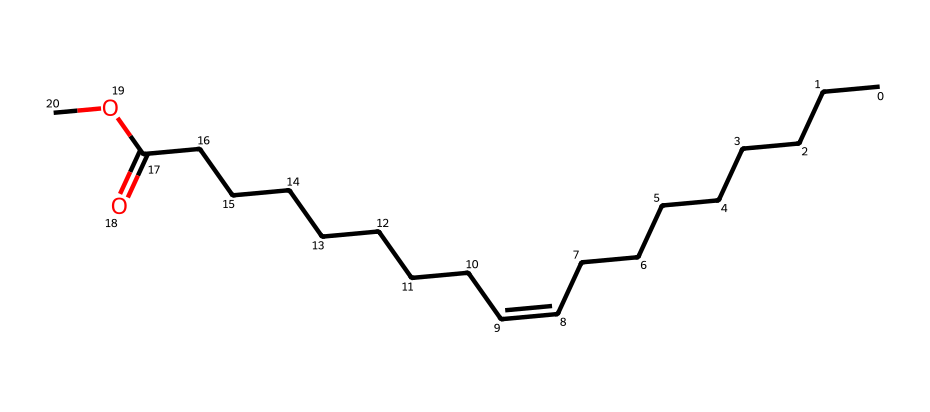how many carbon atoms are present in methyl soyate? The SMILES representation shows multiple "C" symbols, which indicate carbon atoms. By counting them in the structure, we find that there are 18 carbon atoms in total.
Answer: 18 what is the functional group present in methyl soyate? Looking at the SMILES, the component "C(=O)O" indicates the presence of a carboxylate group, which is characteristic of esters. This shows that methyl soyate contains an ester functional group.
Answer: ester how many double bonds are there in the molecular structure? The notation "/C=C\" in the SMILES indicates the presence of one double bond in the compound. Counting the double bond signifies that there is only one in the molecular structure of methyl soyate.
Answer: 1 what type of solvent is methyl soyate considered? Given that methyl soyate is derived from soy oil and is used in eco-friendly products, it is classified as a biodegradable solvent, suitable for sustainable applications.
Answer: biodegradable what type of bonds are primarily present in methyl soyate? In examining the SMILES, we see that most of the connections between the atoms are single bonds (represented by simply "C" without any symbols) and one double bond. Therefore, we conclude that primarily single bonds are present.
Answer: single bonds what does the presence of the "O" atom indicate in this solvent? The "O" represents oxygen, which is part of the ester group in methyl soyate. This indicates the solvent's potential for reactivity and its role in dissolving certain materials, typical for solvents.
Answer: reactivity 